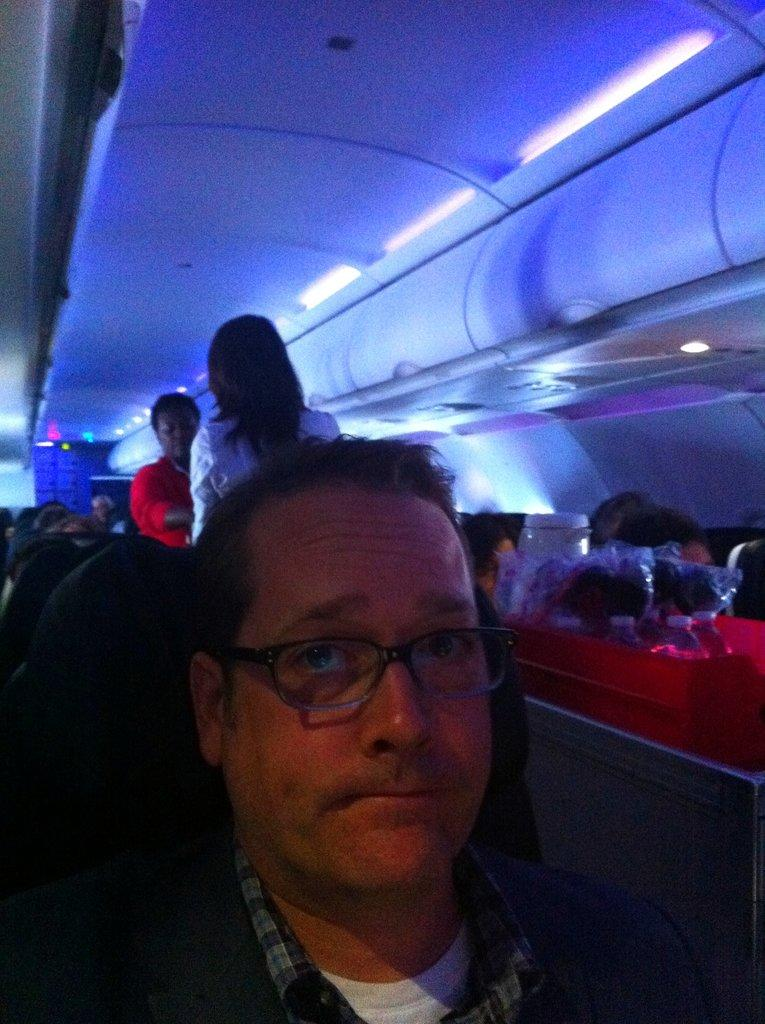What is the setting of the image? The image shows an inside view of a flight. How many people can be seen in the image? There are many people in the image. Can you identify any specific features of one of the individuals? One person is wearing glasses (specs). What can be seen at the top of the image? There are lights visible at the top of the image. What other unspecified items are present in the image? There are other unspecified items in the image. What type of muscle can be seen flexing in the image? There is no muscle visible in the image; it shows an inside view of a flight with many people. Are there any dinosaurs present in the image? No, there are no dinosaurs present in the image. 